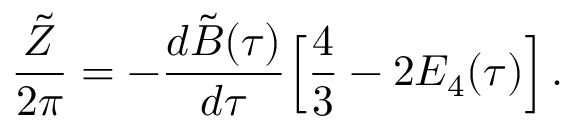Convert formula to latex. <formula><loc_0><loc_0><loc_500><loc_500>{ \frac { \tilde { Z } } { 2 \pi } } = - { \frac { d { \tilde { B } } ( \tau ) } { d \tau } } \left [ { \frac { 4 } { 3 } } - 2 E _ { 4 } ( \tau ) \right ] \, .</formula> 